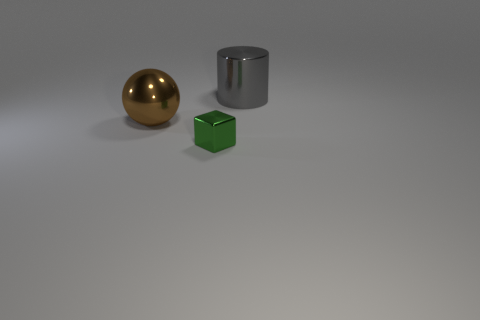There is a large shiny object that is on the right side of the large metallic thing that is on the left side of the big shiny cylinder; what color is it?
Offer a terse response. Gray. Do the big gray cylinder and the thing that is in front of the big brown metal object have the same material?
Your answer should be compact. Yes. There is a big object that is on the right side of the brown ball; what is its material?
Make the answer very short. Metal. Are there the same number of big brown things that are to the right of the large brown thing and brown objects?
Provide a short and direct response. No. Is there any other thing that has the same size as the metal cylinder?
Give a very brief answer. Yes. What is the material of the thing that is behind the big metallic thing that is to the left of the gray shiny cylinder?
Keep it short and to the point. Metal. The shiny object that is both in front of the gray thing and on the right side of the brown shiny thing has what shape?
Provide a succinct answer. Cube. Is the number of spheres that are right of the tiny green metallic cube less than the number of large purple metal balls?
Provide a succinct answer. No. How big is the object that is in front of the shiny ball?
Give a very brief answer. Small. What number of big balls have the same color as the cube?
Make the answer very short. 0. 